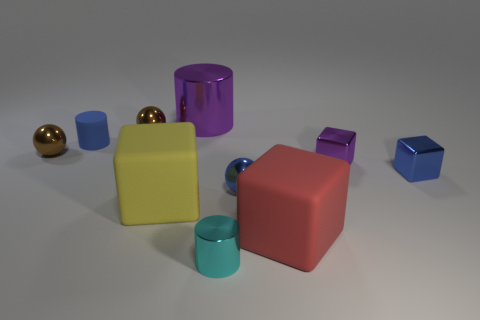Is there anything else that is made of the same material as the red thing?
Your answer should be compact. Yes. What is the material of the large red cube?
Make the answer very short. Rubber. Are there more large purple shiny cylinders than large blue metallic cylinders?
Provide a succinct answer. Yes. Does the cyan metallic object have the same shape as the large purple thing?
Keep it short and to the point. Yes. Are there any other things that have the same shape as the large purple object?
Offer a terse response. Yes. There is a large rubber block to the left of the tiny metal cylinder; is its color the same as the big cube that is to the right of the blue metallic sphere?
Make the answer very short. No. Is the number of shiny cylinders in front of the large yellow object less than the number of blue balls in front of the tiny rubber thing?
Provide a short and direct response. No. There is a blue shiny object to the left of the large red block; what shape is it?
Your response must be concise. Sphere. There is a tiny cube that is the same color as the big cylinder; what is its material?
Offer a very short reply. Metal. What number of other things are made of the same material as the yellow block?
Provide a short and direct response. 2. 